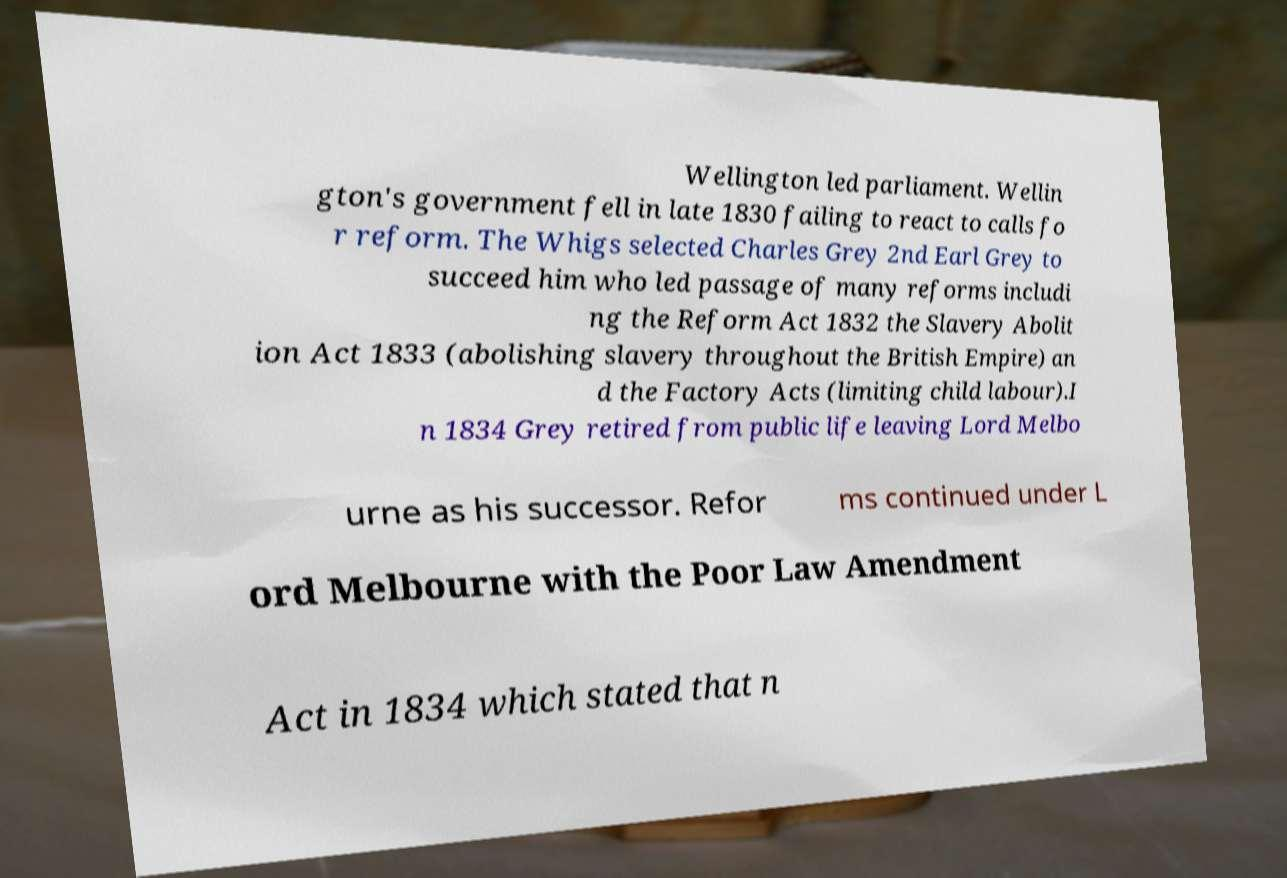Please read and relay the text visible in this image. What does it say? Wellington led parliament. Wellin gton's government fell in late 1830 failing to react to calls fo r reform. The Whigs selected Charles Grey 2nd Earl Grey to succeed him who led passage of many reforms includi ng the Reform Act 1832 the Slavery Abolit ion Act 1833 (abolishing slavery throughout the British Empire) an d the Factory Acts (limiting child labour).I n 1834 Grey retired from public life leaving Lord Melbo urne as his successor. Refor ms continued under L ord Melbourne with the Poor Law Amendment Act in 1834 which stated that n 